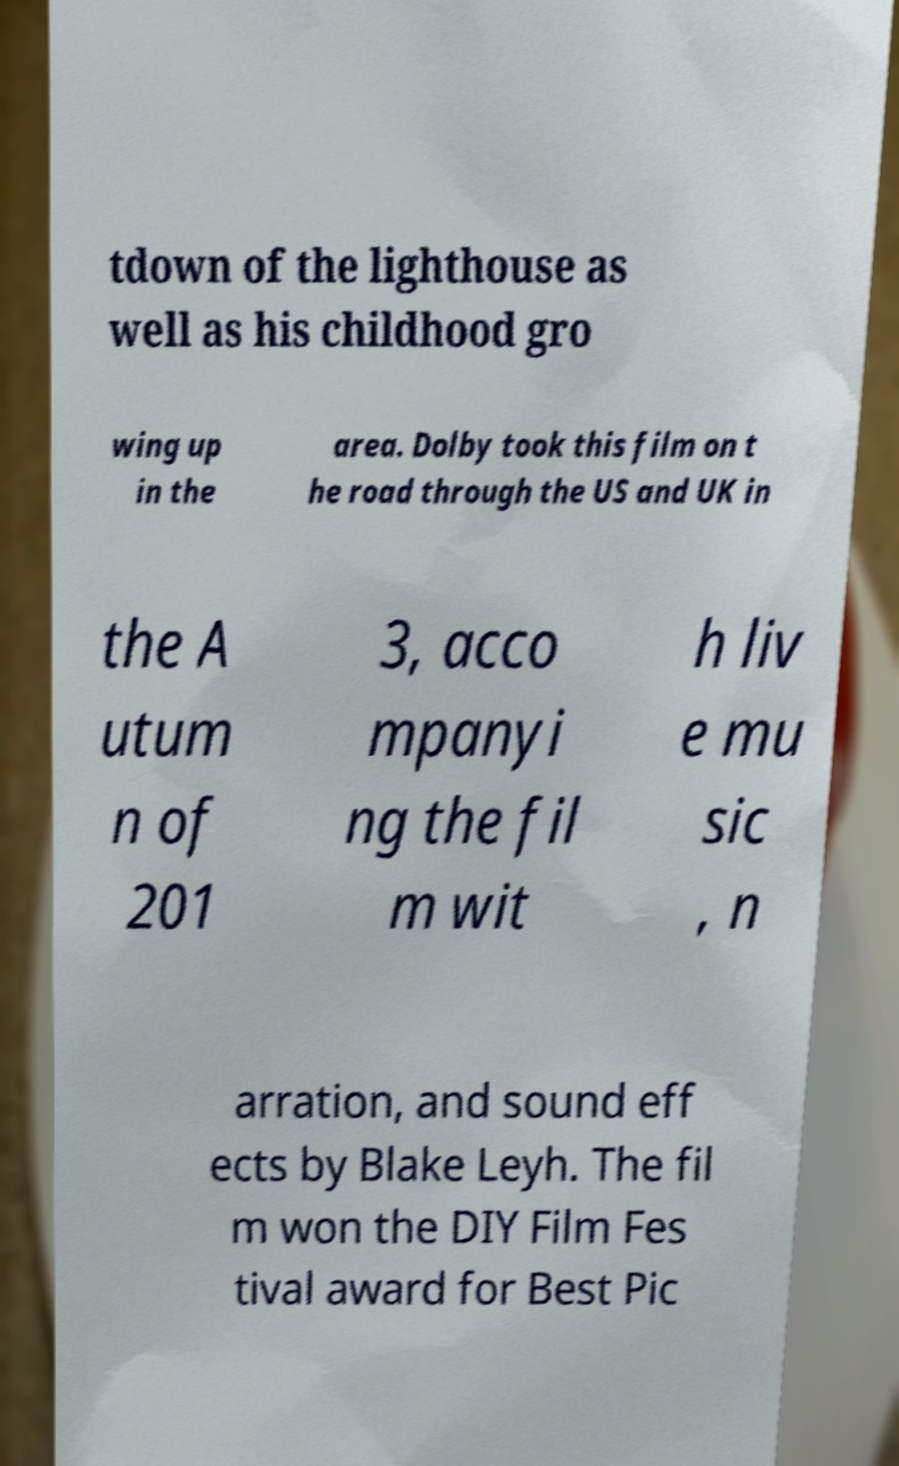Please identify and transcribe the text found in this image. tdown of the lighthouse as well as his childhood gro wing up in the area. Dolby took this film on t he road through the US and UK in the A utum n of 201 3, acco mpanyi ng the fil m wit h liv e mu sic , n arration, and sound eff ects by Blake Leyh. The fil m won the DIY Film Fes tival award for Best Pic 